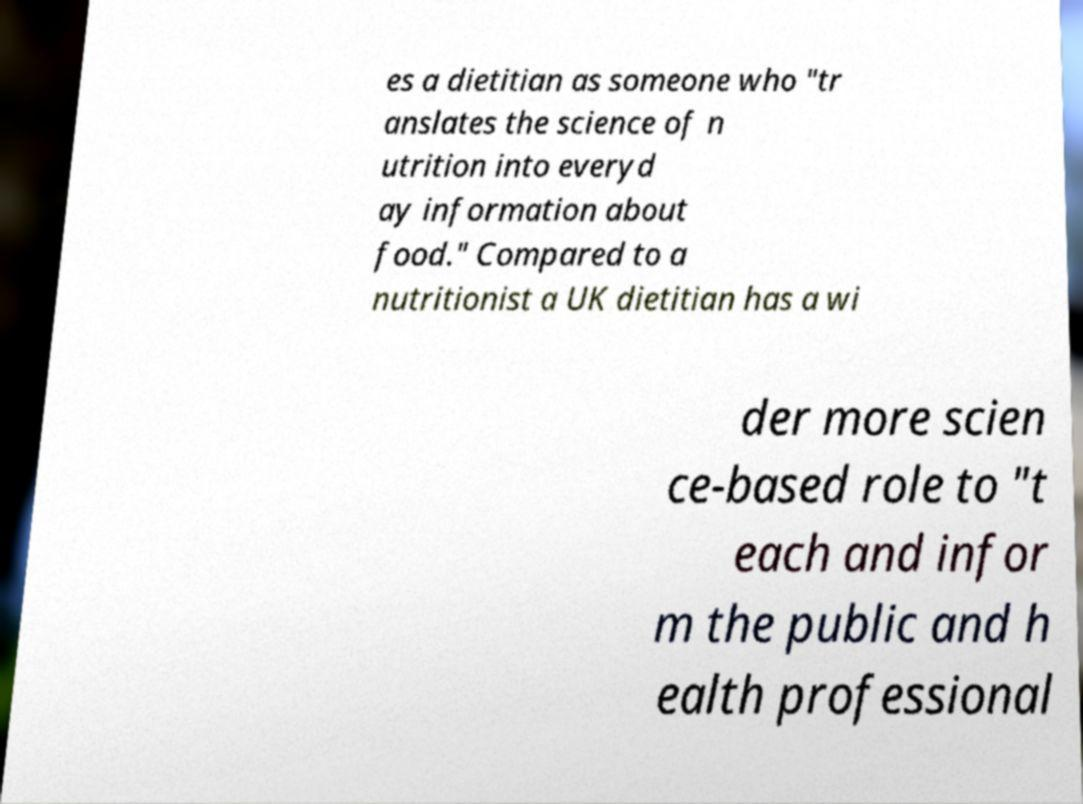Could you assist in decoding the text presented in this image and type it out clearly? es a dietitian as someone who "tr anslates the science of n utrition into everyd ay information about food." Compared to a nutritionist a UK dietitian has a wi der more scien ce-based role to "t each and infor m the public and h ealth professional 